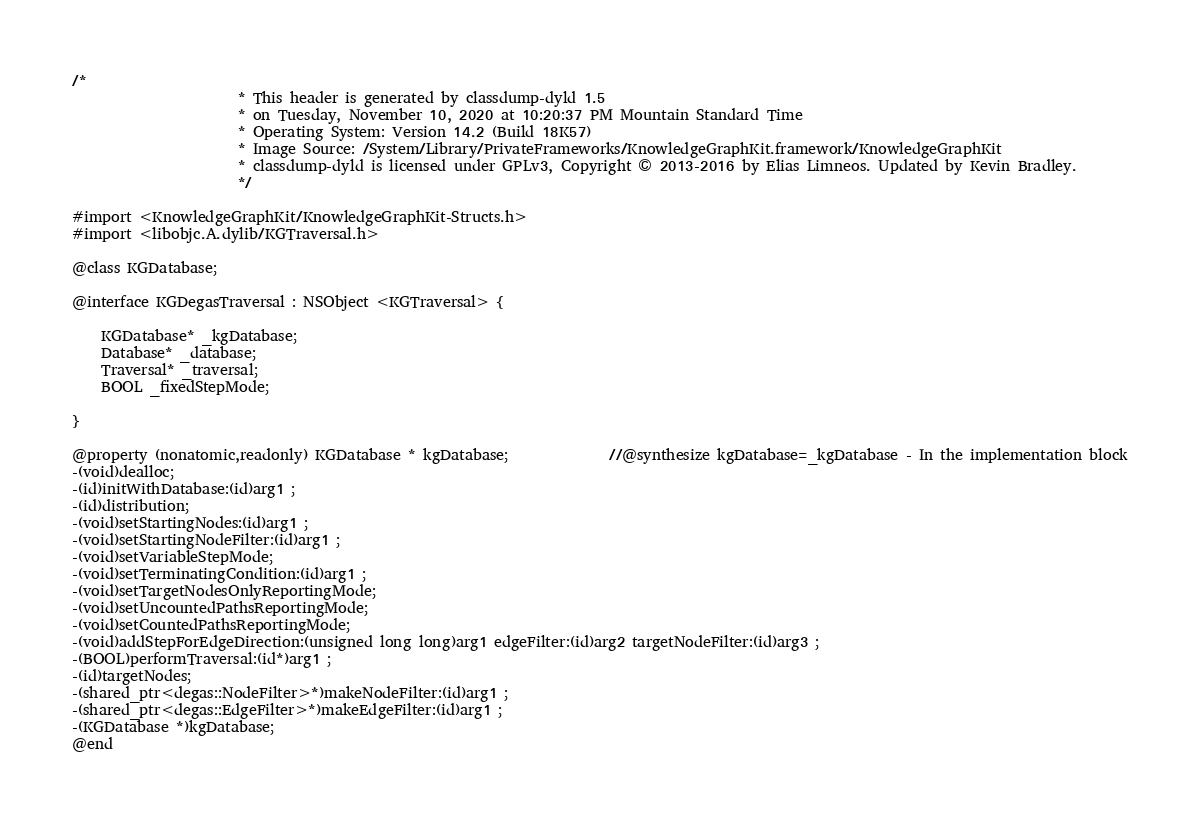<code> <loc_0><loc_0><loc_500><loc_500><_C_>/*
                       * This header is generated by classdump-dyld 1.5
                       * on Tuesday, November 10, 2020 at 10:20:37 PM Mountain Standard Time
                       * Operating System: Version 14.2 (Build 18K57)
                       * Image Source: /System/Library/PrivateFrameworks/KnowledgeGraphKit.framework/KnowledgeGraphKit
                       * classdump-dyld is licensed under GPLv3, Copyright © 2013-2016 by Elias Limneos. Updated by Kevin Bradley.
                       */

#import <KnowledgeGraphKit/KnowledgeGraphKit-Structs.h>
#import <libobjc.A.dylib/KGTraversal.h>

@class KGDatabase;

@interface KGDegasTraversal : NSObject <KGTraversal> {

	KGDatabase* _kgDatabase;
	Database* _database;
	Traversal* _traversal;
	BOOL _fixedStepMode;

}

@property (nonatomic,readonly) KGDatabase * kgDatabase;              //@synthesize kgDatabase=_kgDatabase - In the implementation block
-(void)dealloc;
-(id)initWithDatabase:(id)arg1 ;
-(id)distribution;
-(void)setStartingNodes:(id)arg1 ;
-(void)setStartingNodeFilter:(id)arg1 ;
-(void)setVariableStepMode;
-(void)setTerminatingCondition:(id)arg1 ;
-(void)setTargetNodesOnlyReportingMode;
-(void)setUncountedPathsReportingMode;
-(void)setCountedPathsReportingMode;
-(void)addStepForEdgeDirection:(unsigned long long)arg1 edgeFilter:(id)arg2 targetNodeFilter:(id)arg3 ;
-(BOOL)performTraversal:(id*)arg1 ;
-(id)targetNodes;
-(shared_ptr<degas::NodeFilter>*)makeNodeFilter:(id)arg1 ;
-(shared_ptr<degas::EdgeFilter>*)makeEdgeFilter:(id)arg1 ;
-(KGDatabase *)kgDatabase;
@end

</code> 